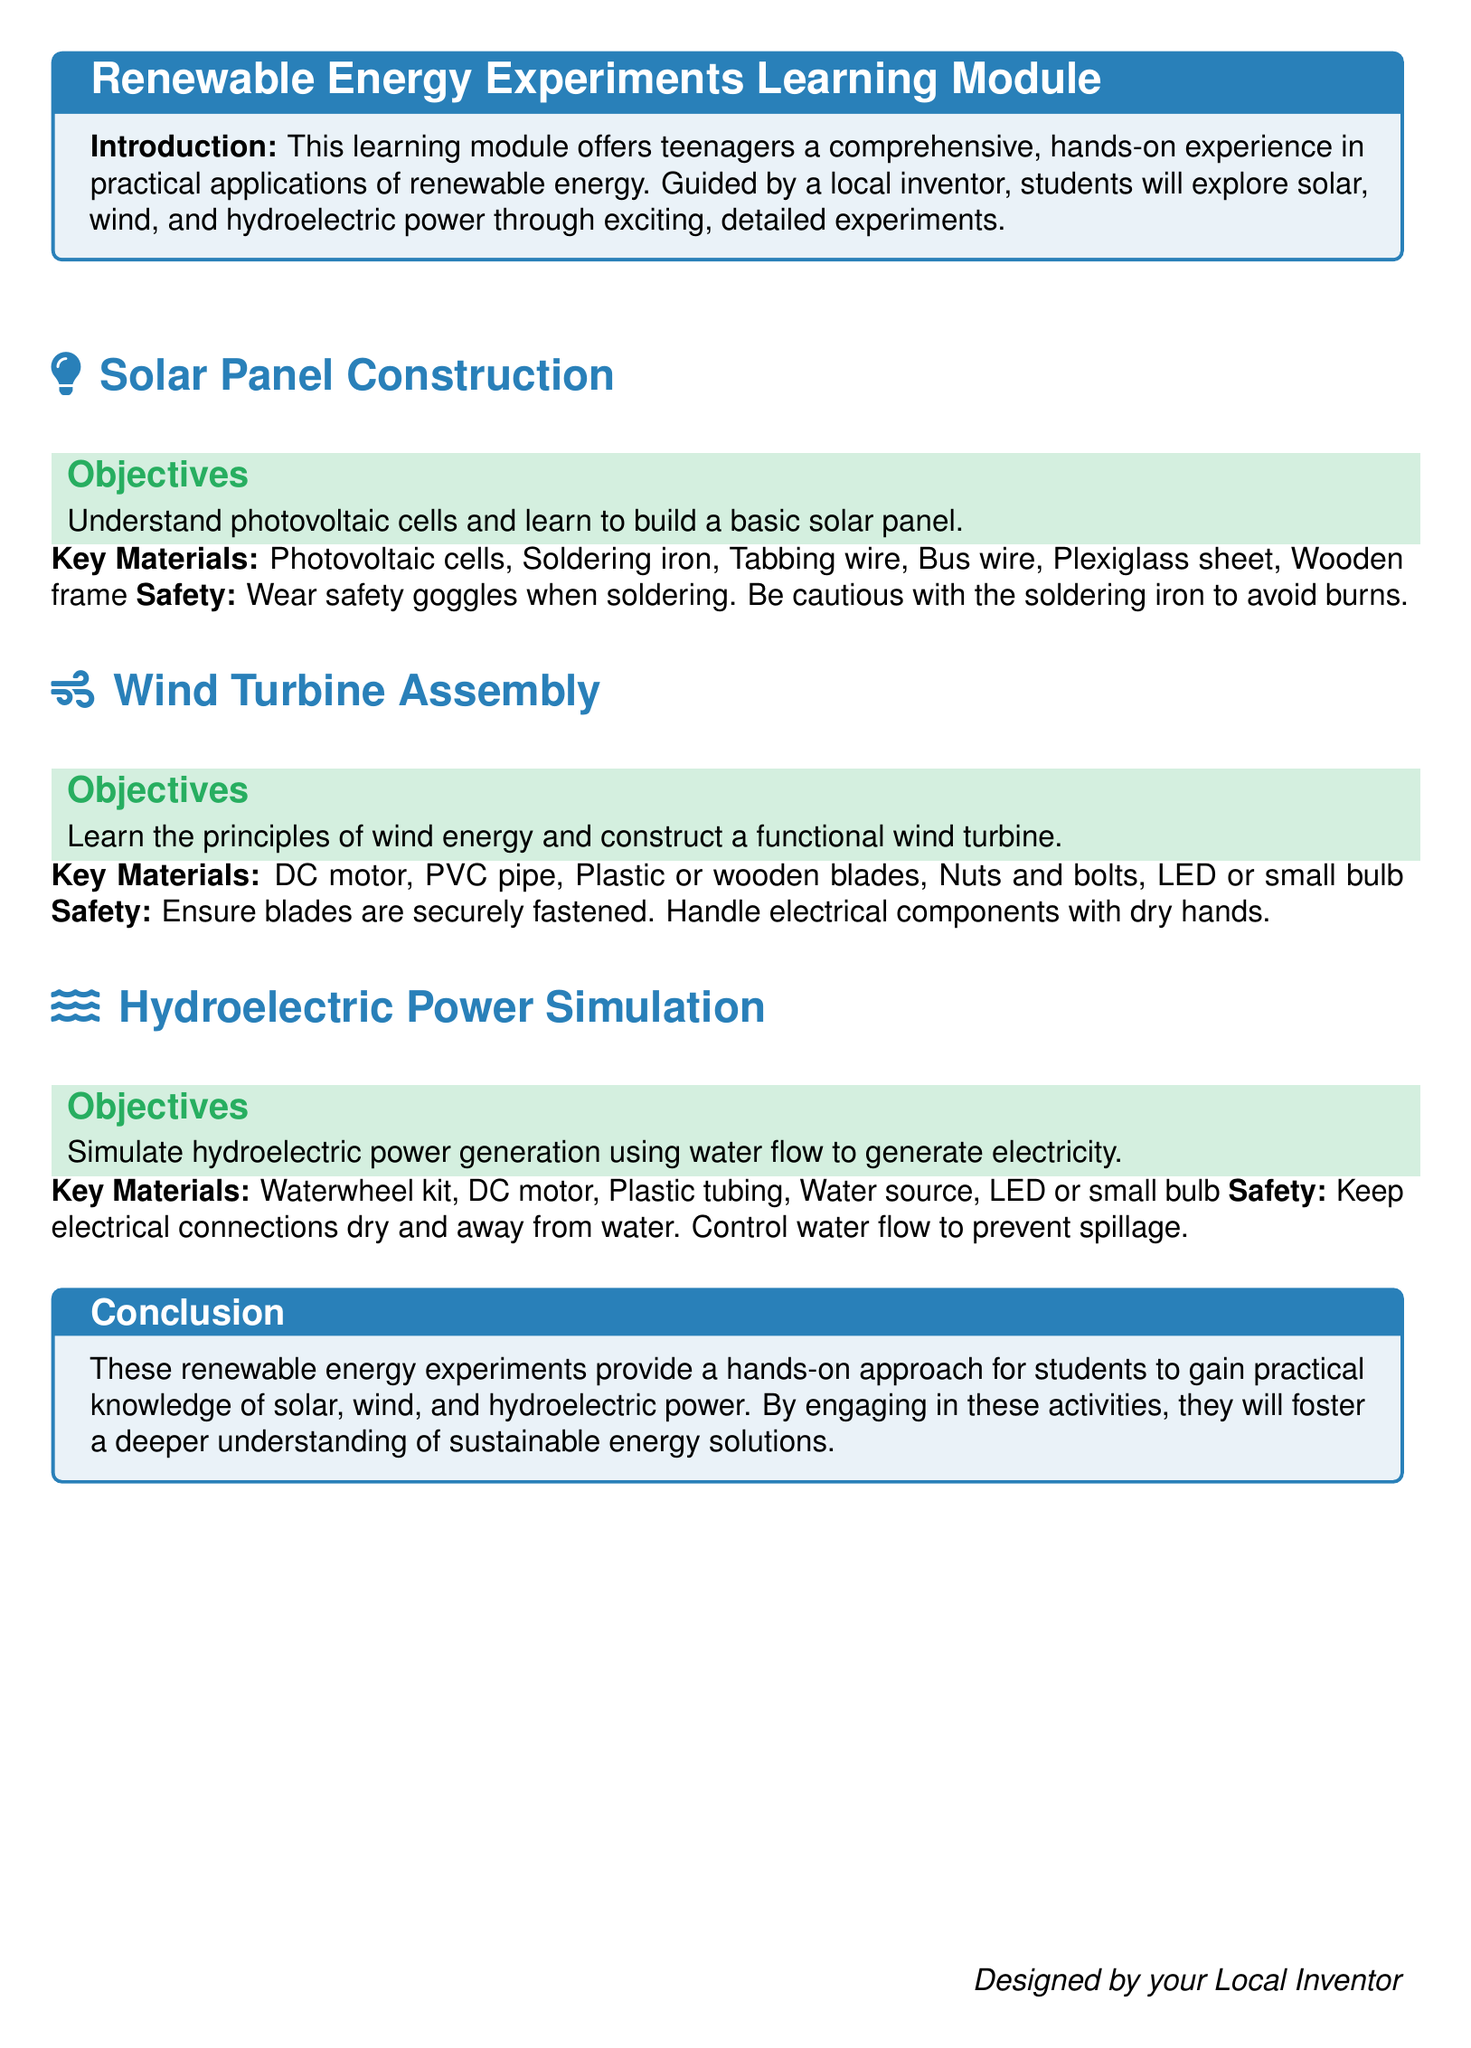What is the focus of the learning module? The focus of the learning module is to provide hands-on experience in practical applications of renewable energy.
Answer: Renewable energy What are the objectives of the solar panel construction section? The objectives for solar panel construction are to understand photovoltaic cells and learn to build a basic solar panel.
Answer: Understand photovoltaic cells and learn to build a basic solar panel What key material is used for the wind turbine assembly? The key materials listed for wind turbine assembly include a DC motor, PVC pipe, and blades.
Answer: DC motor What safety precaution is mentioned for soldering in the solar panel construction? The document indicates that safety goggles should be worn when soldering.
Answer: Wear safety goggles How many components are listed for the hydroelectric power simulation? The hydroelectric power simulation lists five key materials and components for the experiment.
Answer: Five What is the conclusion of the learning module? The conclusion emphasizes hands-on approaches that foster a deeper understanding of sustainable energy solutions.
Answer: Hands-on approach for sustainable energy solutions Which section focuses on simulating power generation? The section that focuses on simulating power generation is hydroelectric power simulation.
Answer: Hydroelectric power simulation What should you keep dry during the hydroelectric power simulation? The document states to keep electrical connections dry and away from water during the simulation.
Answer: Electrical connections What kind of energy does the wind turbine assembly section focus on? The wind turbine assembly section focuses on the principles of wind energy.
Answer: Wind energy 